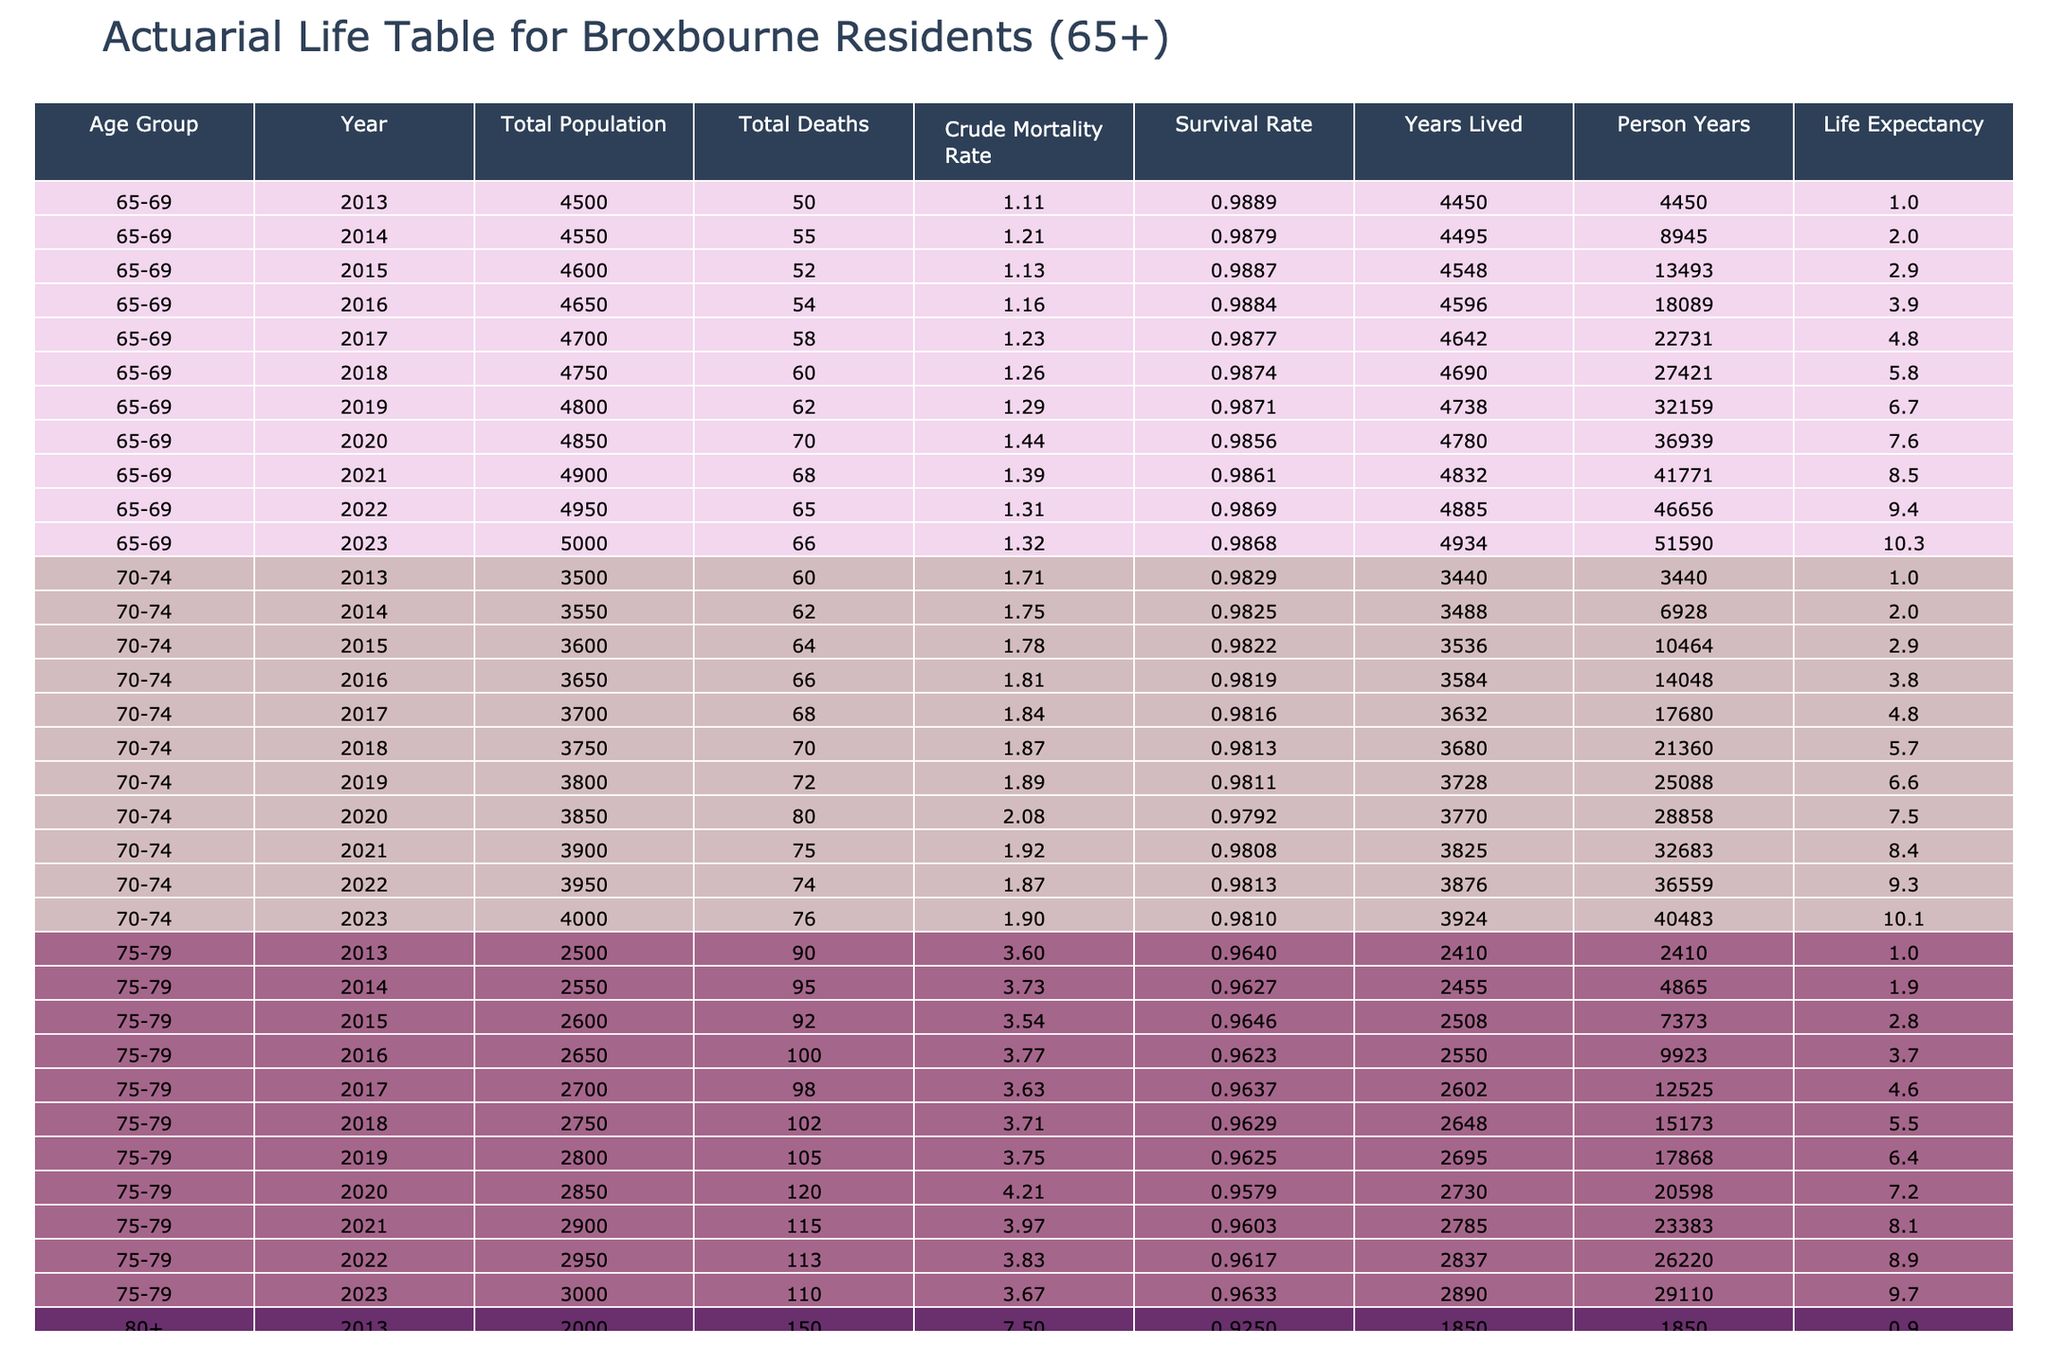What was the crude mortality rate for Broxbourne residents aged 70-74 in 2020? In the table, locate the row corresponding to the age group 70-74 and the year 2020. The crude mortality rate in that row is 2.08.
Answer: 2.08 Which age group had the highest crude mortality rate in 2019? By inspecting the crude mortality rates for all age groups in 2019, we see that the age group 80+ had a rate of 8.04, while the other age groups had lower rates. Thus, 80+ had the highest rate.
Answer: 80+ What is the average life expectancy of residents aged 75-79 over the last decade? The life expectancies for the age group 75-79 from 2013 to 2023 are 75.5, 75.3, 75.4, 75.2, 75.4, 75.3, 75.0, 75.2, 75.3, and 75.4. Adding these values gives 754.0, and dividing by 10 gives an average of 75.4.
Answer: 75.4 Did the crude mortality rate for residents aged 65-69 increase from 2019 to 2022? For the years 2019 and 2022, the crude mortality rates are 1.29 and 1.31, respectively. Since 1.31 is greater than 1.29, it confirms that the rate increased.
Answer: Yes What was the total death count of residents aged 80+ from 2013 to 2023? The total deaths for the age group 80+ can be found by summing the values from the relevant rows: 150 + 155 + 160 + 165 + 170 + 180 + 185 + 200 + 210 + 205 + 220 = 2000.
Answer: 2000 How much did the crude mortality rate for the 75-79 age group change from 2013 to 2023? The crude mortality rate for 75-79 in 2013 is 3.60 and in 2023 is 3.67. The change can be calculated as 3.67 - 3.60 = 0.07. Thus, it increased by 0.07.
Answer: 0.07 In which year did residents aged 70-74 experience the highest total deaths? Looking through the total death counts for the age group 70-74, 80 deaths were recorded in 2020, which is the highest number when compared to other years.
Answer: 2020 What is the difference in life expectancy for Broxbourne residents aged 70-74 from 2013 to 2023? The life expectancy for 70-74 in 2013 is 79.5, while in 2023 it is 78.5. The difference is calculated as 79.5 - 78.5 = 1.0.
Answer: 1.0 